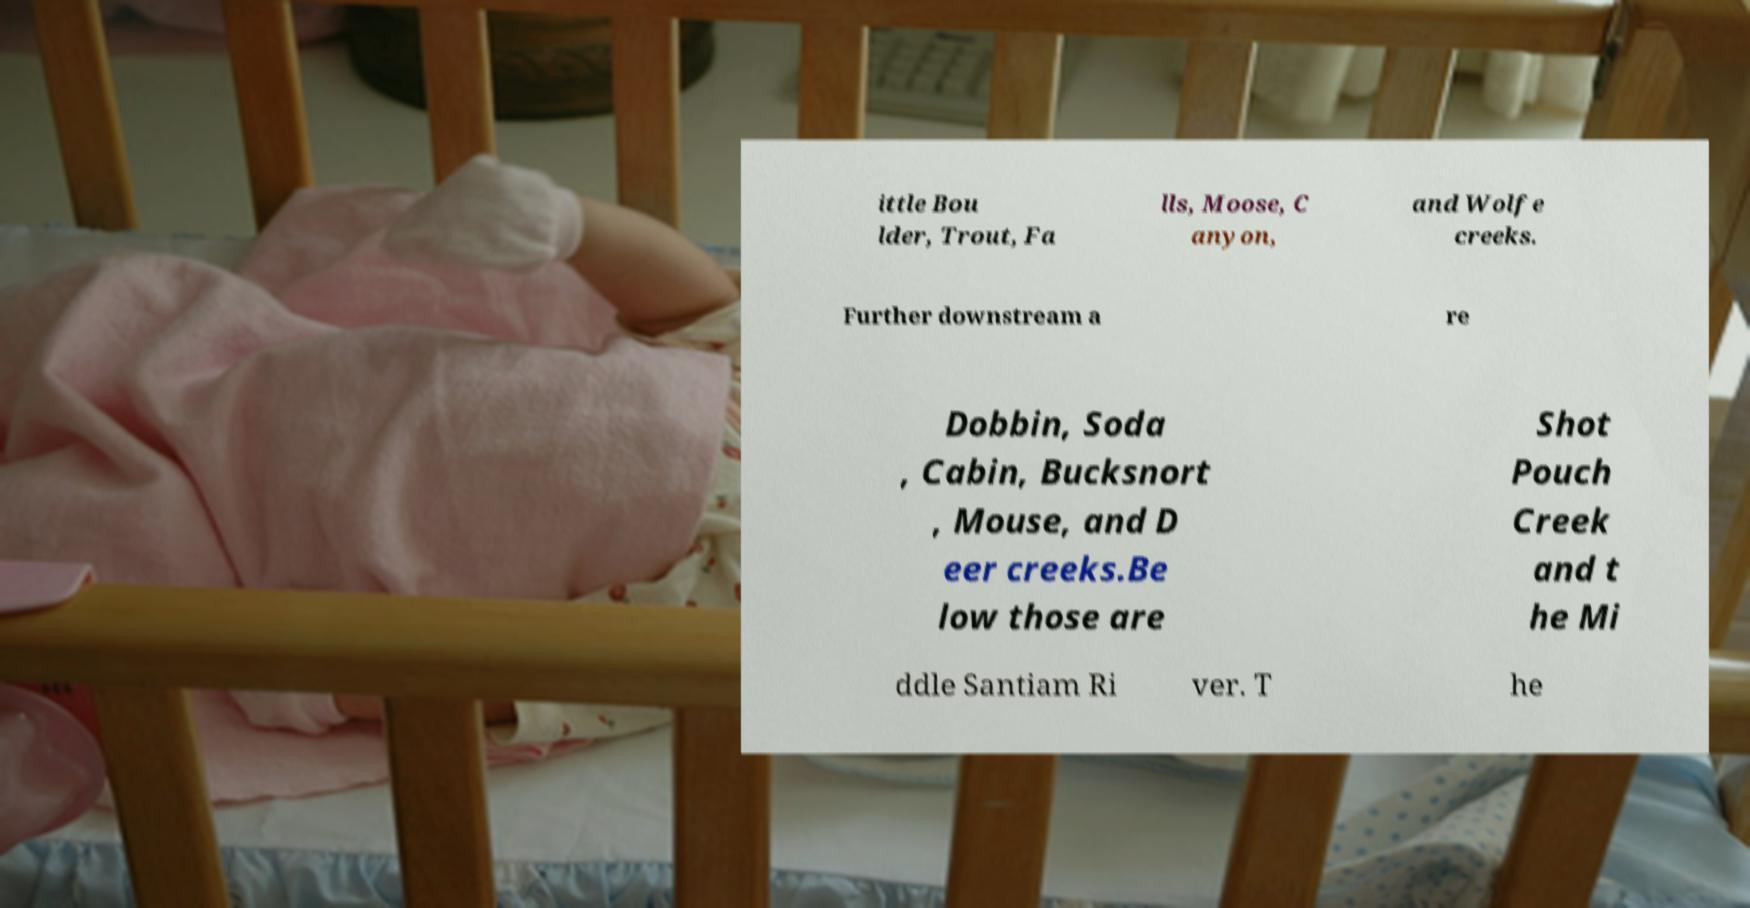What messages or text are displayed in this image? I need them in a readable, typed format. ittle Bou lder, Trout, Fa lls, Moose, C anyon, and Wolfe creeks. Further downstream a re Dobbin, Soda , Cabin, Bucksnort , Mouse, and D eer creeks.Be low those are Shot Pouch Creek and t he Mi ddle Santiam Ri ver. T he 